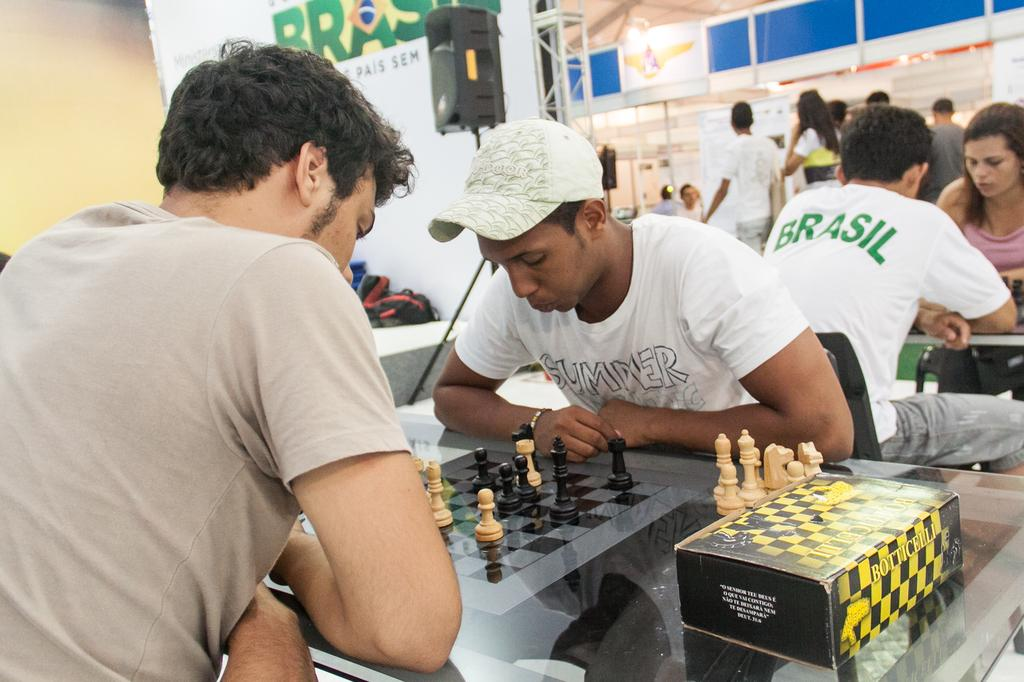<image>
Create a compact narrative representing the image presented. 2 people playing Chess, the man in the back has a Brasil shirt, and the man playing chess, shirt says Summer. 